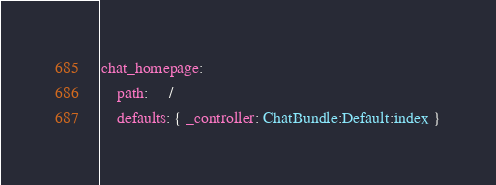<code> <loc_0><loc_0><loc_500><loc_500><_YAML_>chat_homepage:
    path:     /
    defaults: { _controller: ChatBundle:Default:index }
</code> 